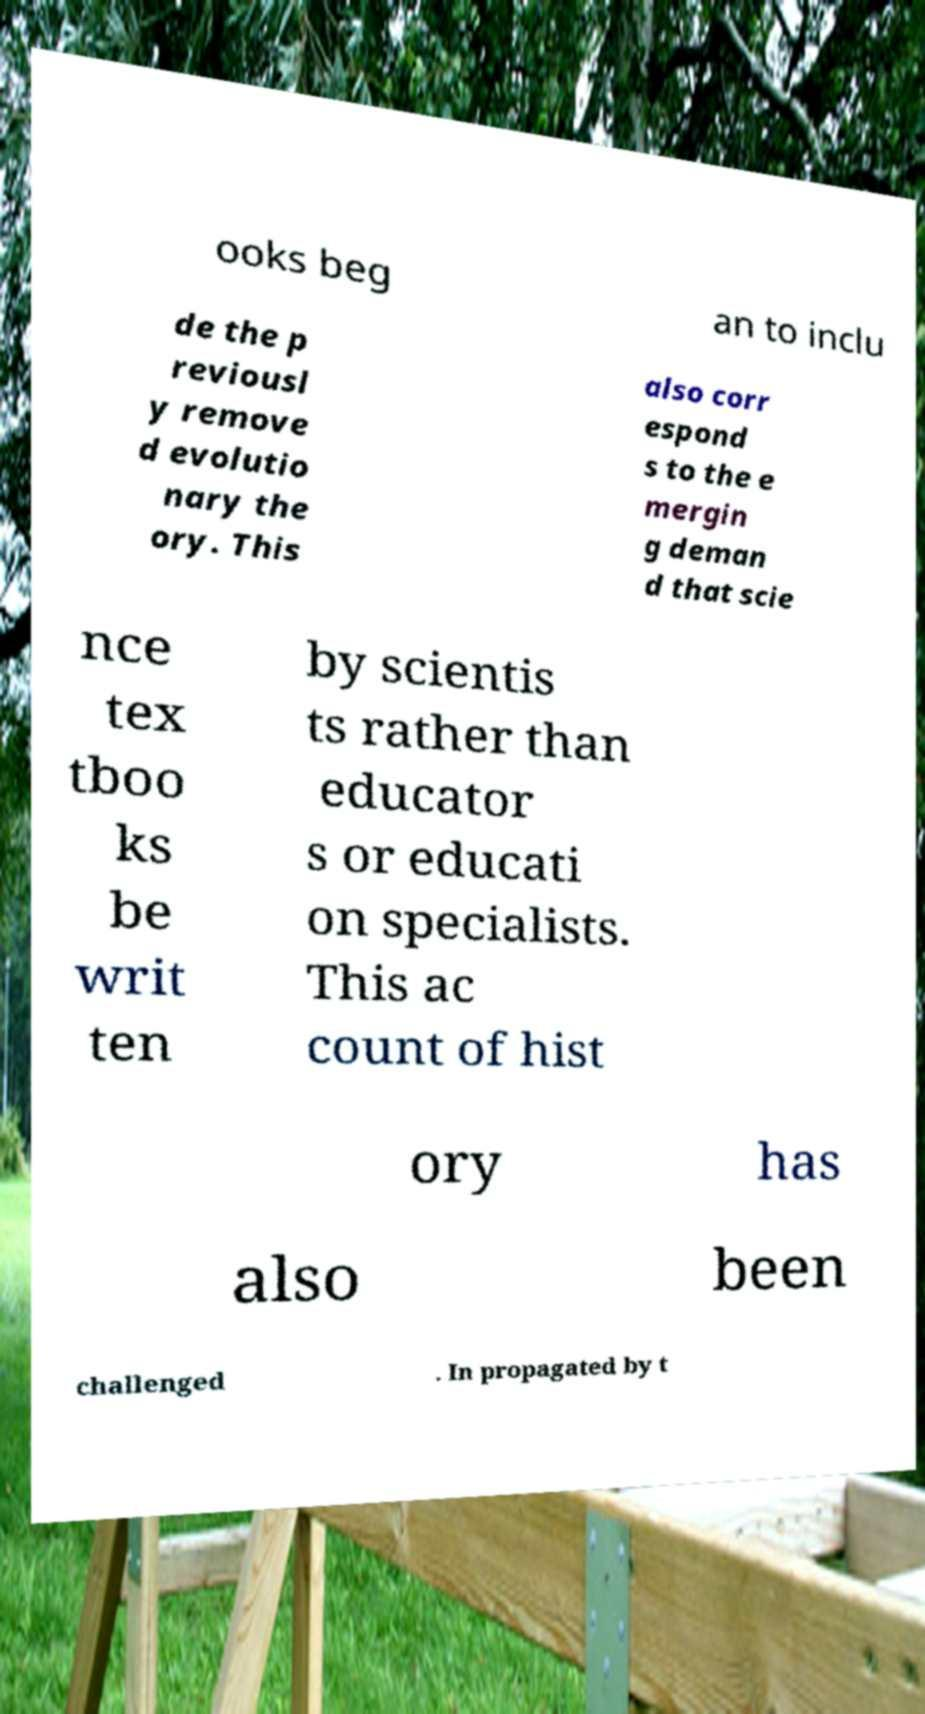Can you accurately transcribe the text from the provided image for me? ooks beg an to inclu de the p reviousl y remove d evolutio nary the ory. This also corr espond s to the e mergin g deman d that scie nce tex tboo ks be writ ten by scientis ts rather than educator s or educati on specialists. This ac count of hist ory has also been challenged . In propagated by t 